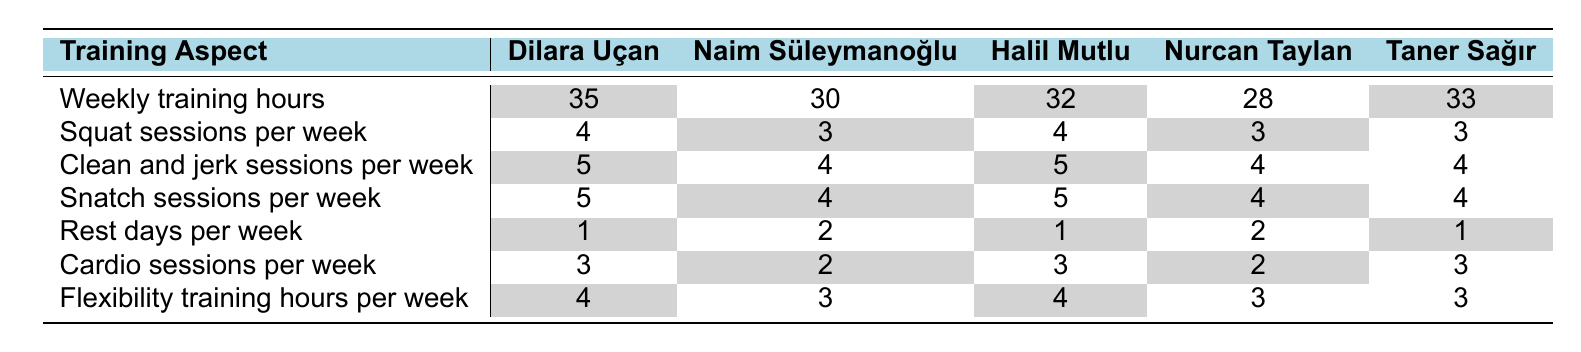What are Dilara Uçan's weekly training hours? According to the table, Dilara Uçan's weekly training hours are listed under her name, which is 35 hours.
Answer: 35 How many squat sessions per week does Taner Sağır perform? The table shows that Taner Sağır has 3 squat sessions per week listed under his name.
Answer: 3 Which weightlifter has the highest number of snatch sessions per week? By comparing the snatch sessions per week across all lifters in the table, Dilara Uçan and Halil Mutlu both have the highest number with 5 sessions.
Answer: Dilara Uçan and Halil Mutlu Does Nurcan Taylan have more flexibility training hours per week than Naim Süleymanoğlu? Nurcan Taylan has 3 flexibility training hours, while Naim Süleymanoğlu has 3 as well, so they are equal.
Answer: No What is the average number of clean and jerk sessions per week among the lifters? The clean and jerk sessions are 5, 4, 5, 4, and 4. Summing these gives 22, and dividing by 5 equals 4.4.
Answer: 4.4 How many rest days per week does Dilara Uçan have compared to Halil Mutlu? Dilara Uçan has 1 rest day while Halil Mutlu also has 1 rest day, so they are equal in this aspect.
Answer: They are equal Which weightlifter has more total cardio sessions per week, Naim Süleymanoğlu or Nurcan Taylan? Naim Süleymanoğlu has 2 cardio sessions while Nurcan Taylan has 2 as well, so they are equal.
Answer: They are equal What is the total number of weekly training hours across all weightlifters? Adding the weekly training hours: 35 + 30 + 32 + 28 + 33 = 158.
Answer: 158 Who has the least number of rest days per week? The table shows Dilara Uçan, Halil Mutlu, and Taner Sağır each have 1 rest day, which is the least among the lifters.
Answer: Dilara Uçan, Halil Mutlu, and Taner Sağır Is it true that all weightlifters have at least 3 squat sessions per week? Searching the table, both Nurcan Taylan and Taner Sağır have only 3 squat sessions, so the statement is true only for those who have 3 or more. Thus, yes, it is true.
Answer: Yes What is the difference between the number of squat sessions of Dilara Uçan and the average of other weightlifters? The average squat sessions of the others are (3 + 4 + 3 + 3) / 4 = 3.25. Dilara has 4. The difference is 4 - 3.25 = 0.75.
Answer: 0.75 